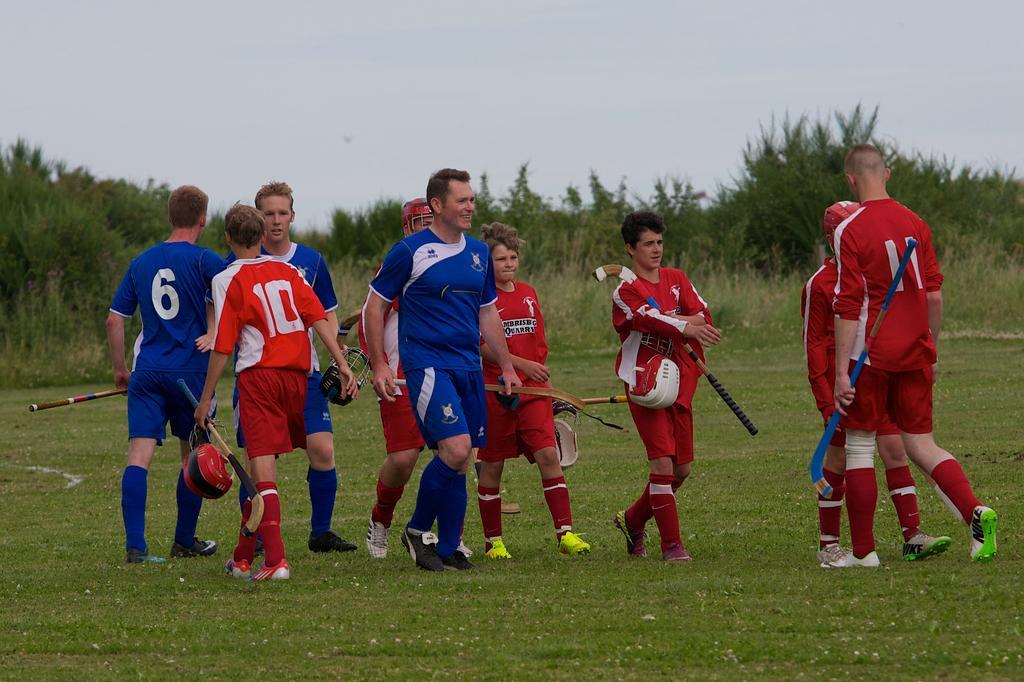How many people are in the image? There are people in the image, but the exact number is not specified. What are the people holding in the image? The people are holding objects in the image. What type of surface is visible on the ground? The ground is visible in the image, and there is grass on the ground. What other vegetation can be seen on the ground? There are plants on the ground in the image. What is visible in the background of the image? The sky is visible in the image. Can you tell me how the spark ignites the hot air balloon in the image? There is no hot air balloon or spark present in the image. 